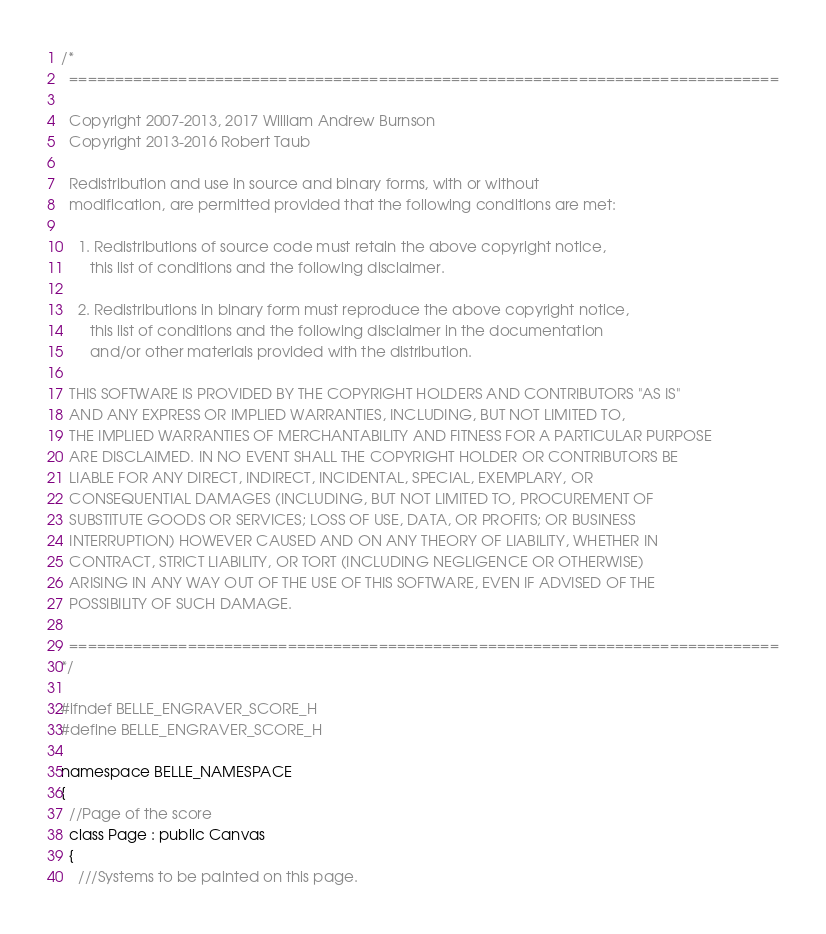<code> <loc_0><loc_0><loc_500><loc_500><_C_>/*
  ==============================================================================

  Copyright 2007-2013, 2017 William Andrew Burnson
  Copyright 2013-2016 Robert Taub

  Redistribution and use in source and binary forms, with or without
  modification, are permitted provided that the following conditions are met:

    1. Redistributions of source code must retain the above copyright notice,
       this list of conditions and the following disclaimer.

    2. Redistributions in binary form must reproduce the above copyright notice,
       this list of conditions and the following disclaimer in the documentation
       and/or other materials provided with the distribution.

  THIS SOFTWARE IS PROVIDED BY THE COPYRIGHT HOLDERS AND CONTRIBUTORS "AS IS"
  AND ANY EXPRESS OR IMPLIED WARRANTIES, INCLUDING, BUT NOT LIMITED TO,
  THE IMPLIED WARRANTIES OF MERCHANTABILITY AND FITNESS FOR A PARTICULAR PURPOSE
  ARE DISCLAIMED. IN NO EVENT SHALL THE COPYRIGHT HOLDER OR CONTRIBUTORS BE
  LIABLE FOR ANY DIRECT, INDIRECT, INCIDENTAL, SPECIAL, EXEMPLARY, OR
  CONSEQUENTIAL DAMAGES (INCLUDING, BUT NOT LIMITED TO, PROCUREMENT OF
  SUBSTITUTE GOODS OR SERVICES; LOSS OF USE, DATA, OR PROFITS; OR BUSINESS
  INTERRUPTION) HOWEVER CAUSED AND ON ANY THEORY OF LIABILITY, WHETHER IN
  CONTRACT, STRICT LIABILITY, OR TORT (INCLUDING NEGLIGENCE OR OTHERWISE)
  ARISING IN ANY WAY OUT OF THE USE OF THIS SOFTWARE, EVEN IF ADVISED OF THE
  POSSIBILITY OF SUCH DAMAGE.

  ==============================================================================
*/

#ifndef BELLE_ENGRAVER_SCORE_H
#define BELLE_ENGRAVER_SCORE_H

namespace BELLE_NAMESPACE
{
  //Page of the score
  class Page : public Canvas
  {
    ///Systems to be painted on this page.</code> 